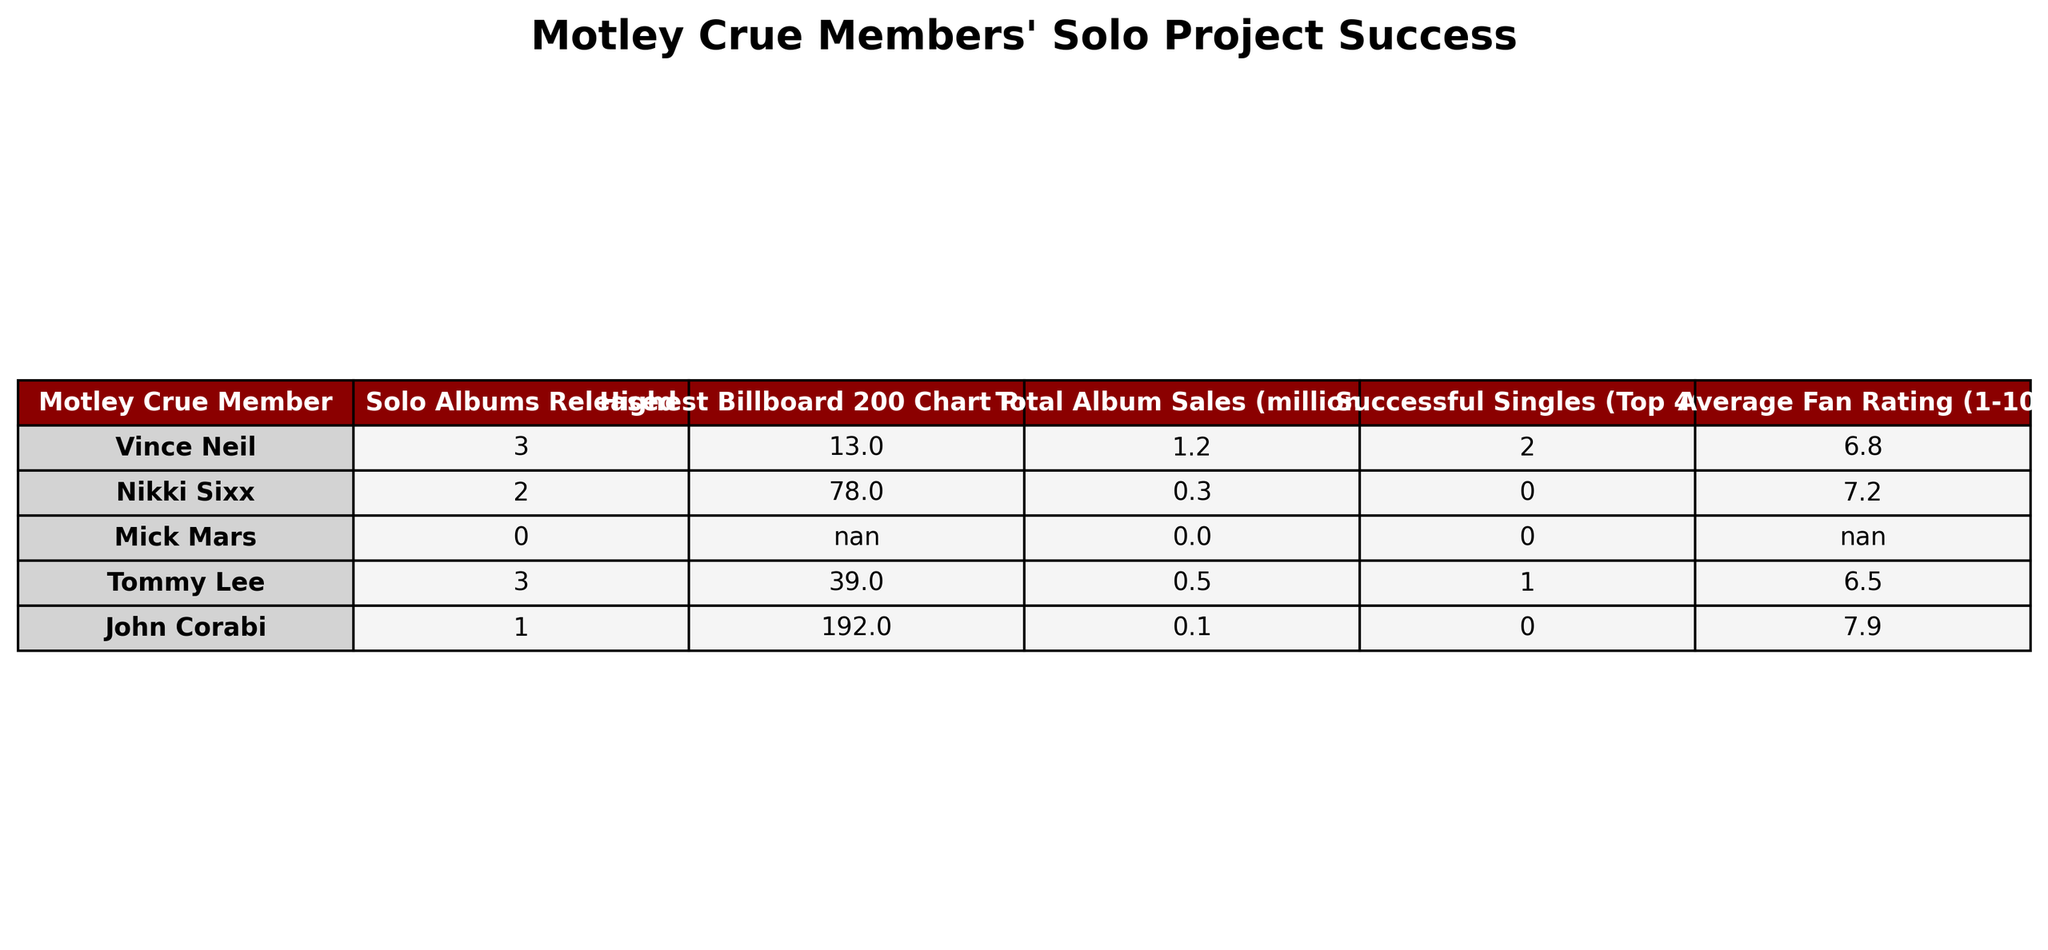What is the highest Billboard 200 chart position achieved by Vince Neil? According to the table, Vince Neil's highest Billboard 200 chart position is 13.
Answer: 13 How many successful singles did Tommy Lee have? The table indicates that Tommy Lee had 1 successful single that reached the Top 40.
Answer: 1 What is the total album sales in millions for Nikki Sixx? The table shows that Nikki Sixx has total album sales of 0.3 million.
Answer: 0.3 Which Motley Crue member has the highest average fan rating? By reviewing the average fan ratings in the table, John Corabi has the highest rating of 7.9.
Answer: 7.9 How many solo albums were released by Mick Mars? The table states that Mick Mars released 0 solo albums.
Answer: 0 What is the combined total album sales for all members who released solo albums? From the table, we see Vince Neil (1.2M), Nikki Sixx (0.3M), Tommy Lee (0.5M), John Corabi (0.1M), making the total: 1.2 + 0.3 + 0.5 + 0.1 = 2.1 million.
Answer: 2.1 million Is it true that all members of Motley Crue released solo albums? The table provides information that Mick Mars did not release any solo albums, making the statement false.
Answer: False What is the difference in the highest Billboard 200 chart position between Vince Neil and John Corabi? Vince Neil's position is 13, and John Corabi's position is 192. The difference is 192 - 13 = 179.
Answer: 179 Which member has the lowest total album sales? The data shows that John Corabi has the lowest total album sales at 0.1 million.
Answer: 0.1 million Calculate the average fan rating for the members who released at least one solo album. The average is calculated by adding their ratings: (6.8 + 7.2 + 6.5 + 7.9) / 4 = 7.4.
Answer: 7.4 